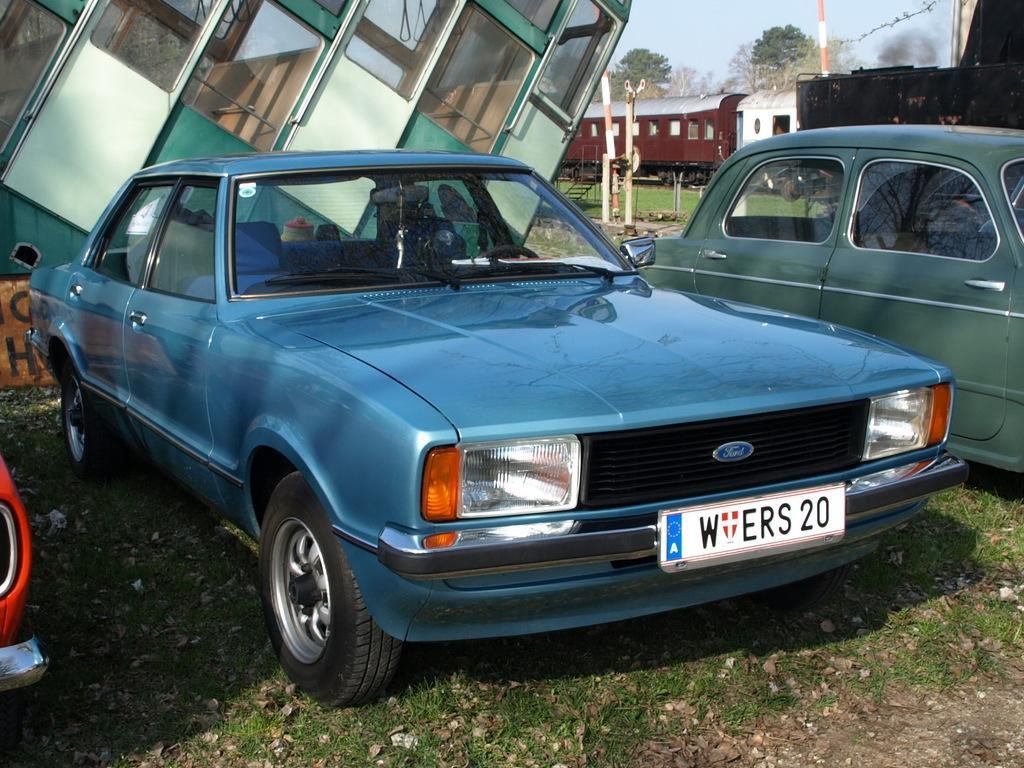Describe this image in one or two sentences. In this image we can see there are few vehicles. In the background there is a train on the track, few poles, trees and the sky. 